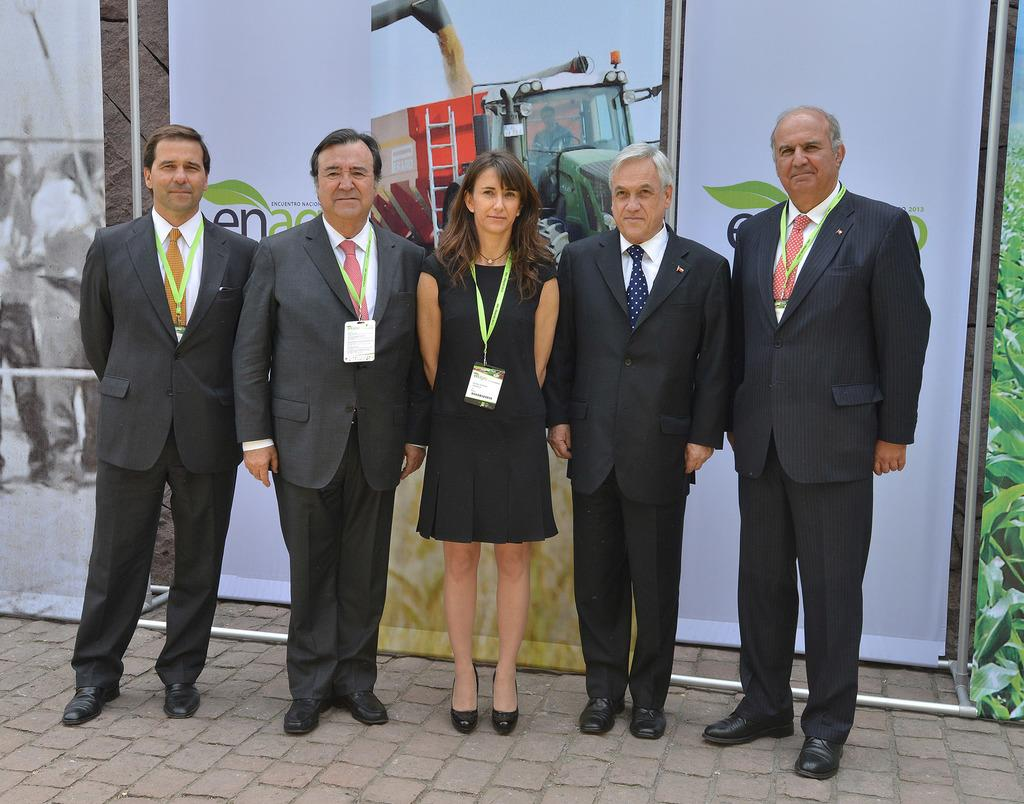How many people are in the image? There is a group of people in the image. What are the people doing in the image? The people are standing on the floor. What can be seen in the background of the image? There are hoardings in the background of the image. What type of doctor is the daughter of the person in the image? There is no doctor or daughter mentioned in the image; it only shows a group of people standing on the floor with hoardings in the background. 